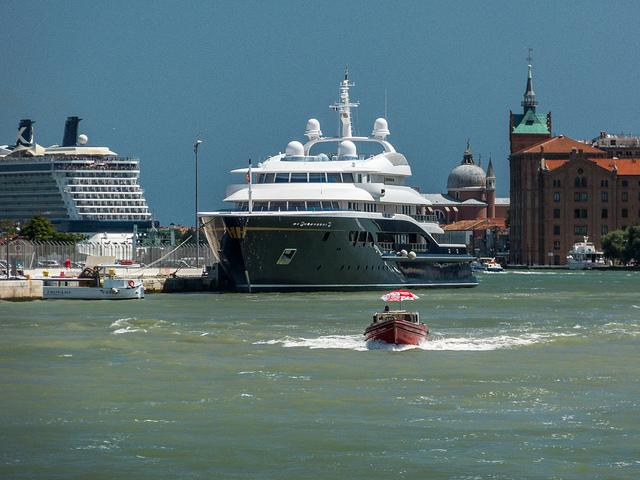Which direction is the large gray ship going?

Choices:
A) south
B) no where
C) east
D) north no where 